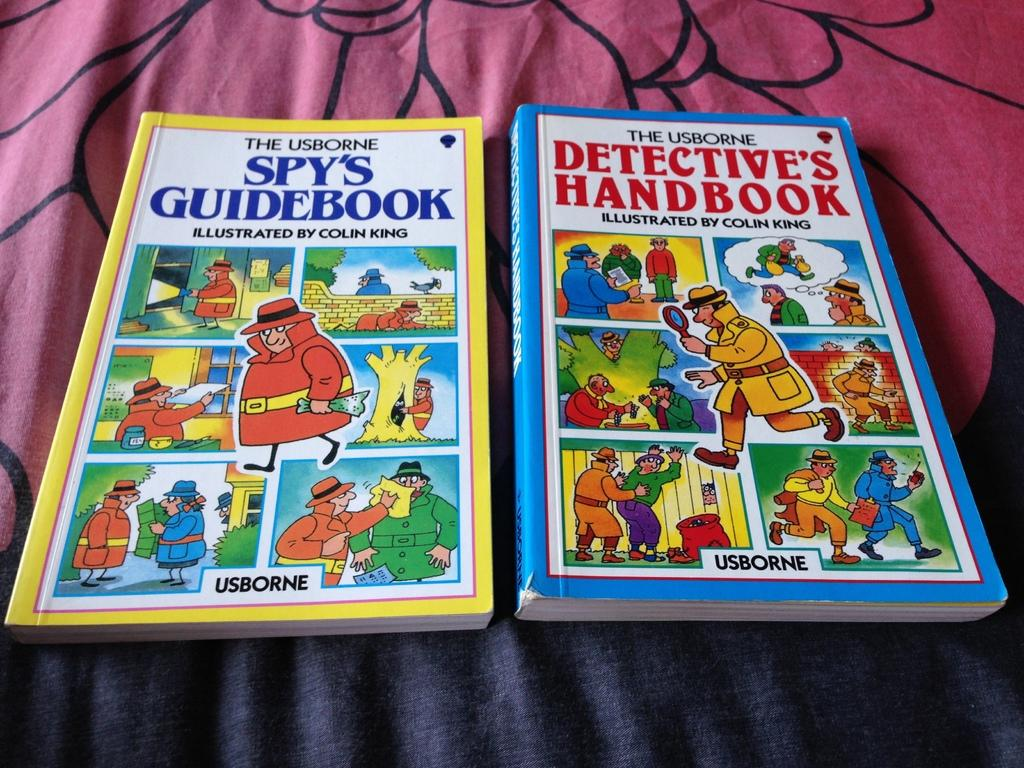Provide a one-sentence caption for the provided image. a yellow and blue comic books  with the word Usborne on top. 